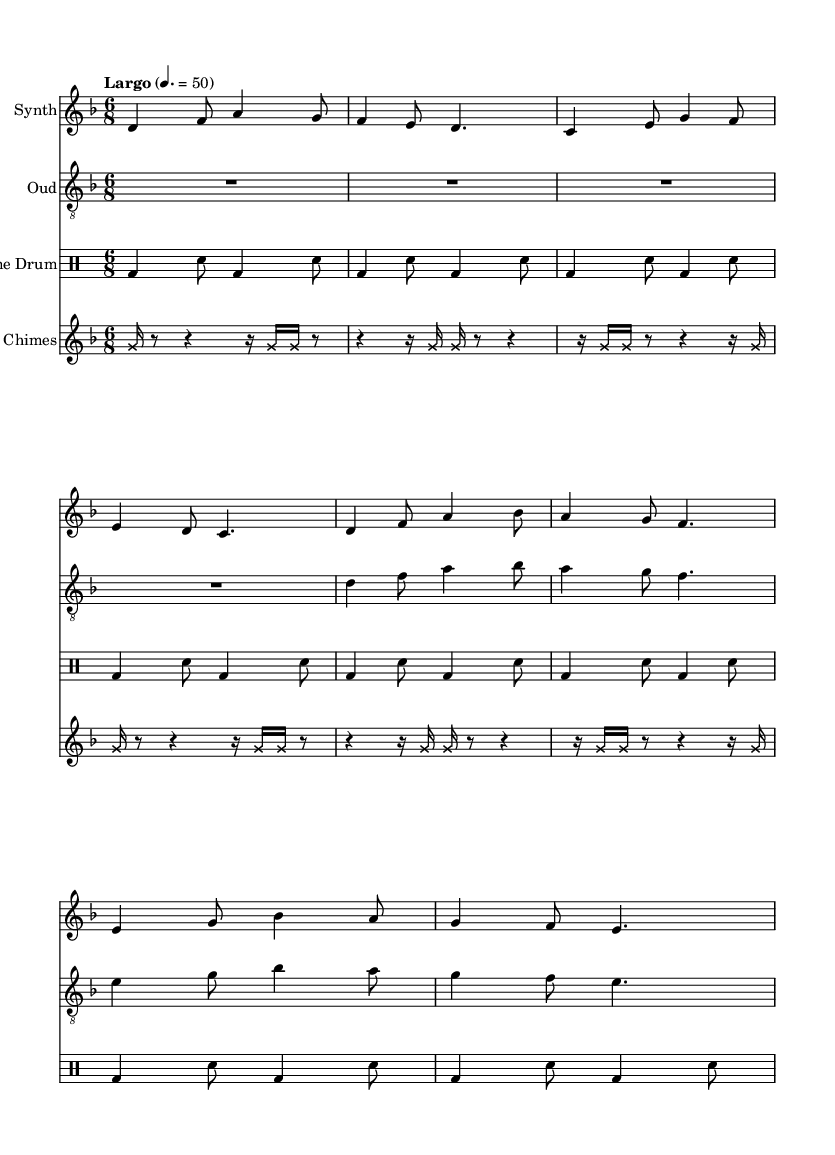What is the key signature of this music? The key signature is D minor, which has one flat (B flat).
Answer: D minor What is the time signature of the piece? The time signature is 6/8, which means there are six eighth notes in each measure.
Answer: 6/8 What is the tempo marking for the composition? The tempo marking is "Largo", indicating a slow pace for the music.
Answer: Largo How many instruments are indicated in the score? The score features four instruments: Synth, Oud, Frame Drum, and Wind Chimes.
Answer: Four What is the rhythmic pattern used by the Frame Drum? The Frame Drum uses a consistent pattern of bass and snare hits in alternating eighth notes within each measure.
Answer: Bass and Snare pattern What is the primary function of Wind Chimes in this composition? The Wind Chimes serve to create atmospheric texture, with a repeated pattern that adds a subtle, ethereal quality to the overall sound.
Answer: Atmospheric texture Which instrument plays the longest sustained notes? The Oud plays longer sustained notes compared to the other instruments, creating a melodic foundation for the piece.
Answer: Oud 